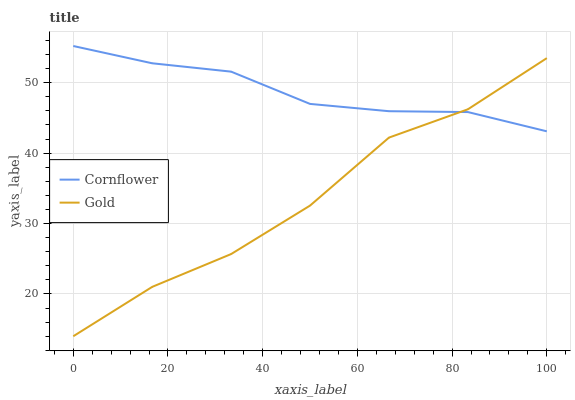Does Gold have the minimum area under the curve?
Answer yes or no. Yes. Does Cornflower have the maximum area under the curve?
Answer yes or no. Yes. Does Gold have the maximum area under the curve?
Answer yes or no. No. Is Cornflower the smoothest?
Answer yes or no. Yes. Is Gold the roughest?
Answer yes or no. Yes. Is Gold the smoothest?
Answer yes or no. No. Does Gold have the lowest value?
Answer yes or no. Yes. Does Cornflower have the highest value?
Answer yes or no. Yes. Does Gold have the highest value?
Answer yes or no. No. Does Cornflower intersect Gold?
Answer yes or no. Yes. Is Cornflower less than Gold?
Answer yes or no. No. Is Cornflower greater than Gold?
Answer yes or no. No. 